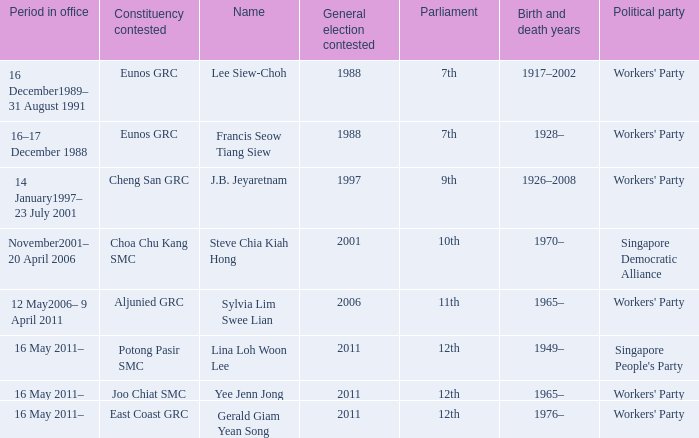What number parliament held it's election in 1997? 9th. 